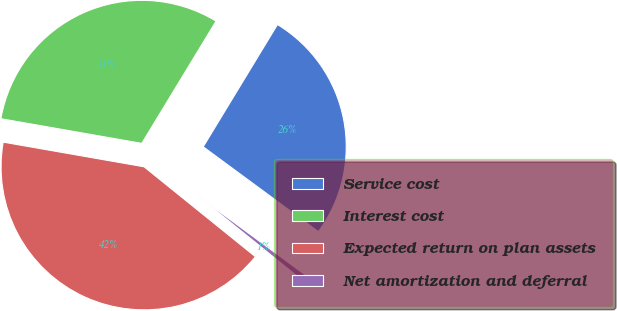Convert chart to OTSL. <chart><loc_0><loc_0><loc_500><loc_500><pie_chart><fcel>Service cost<fcel>Interest cost<fcel>Expected return on plan assets<fcel>Net amortization and deferral<nl><fcel>26.41%<fcel>30.93%<fcel>41.95%<fcel>0.71%<nl></chart> 